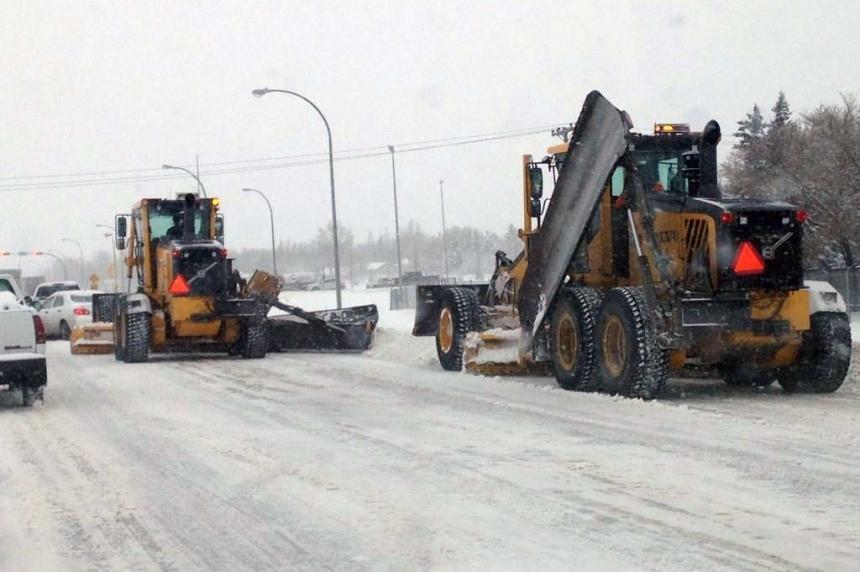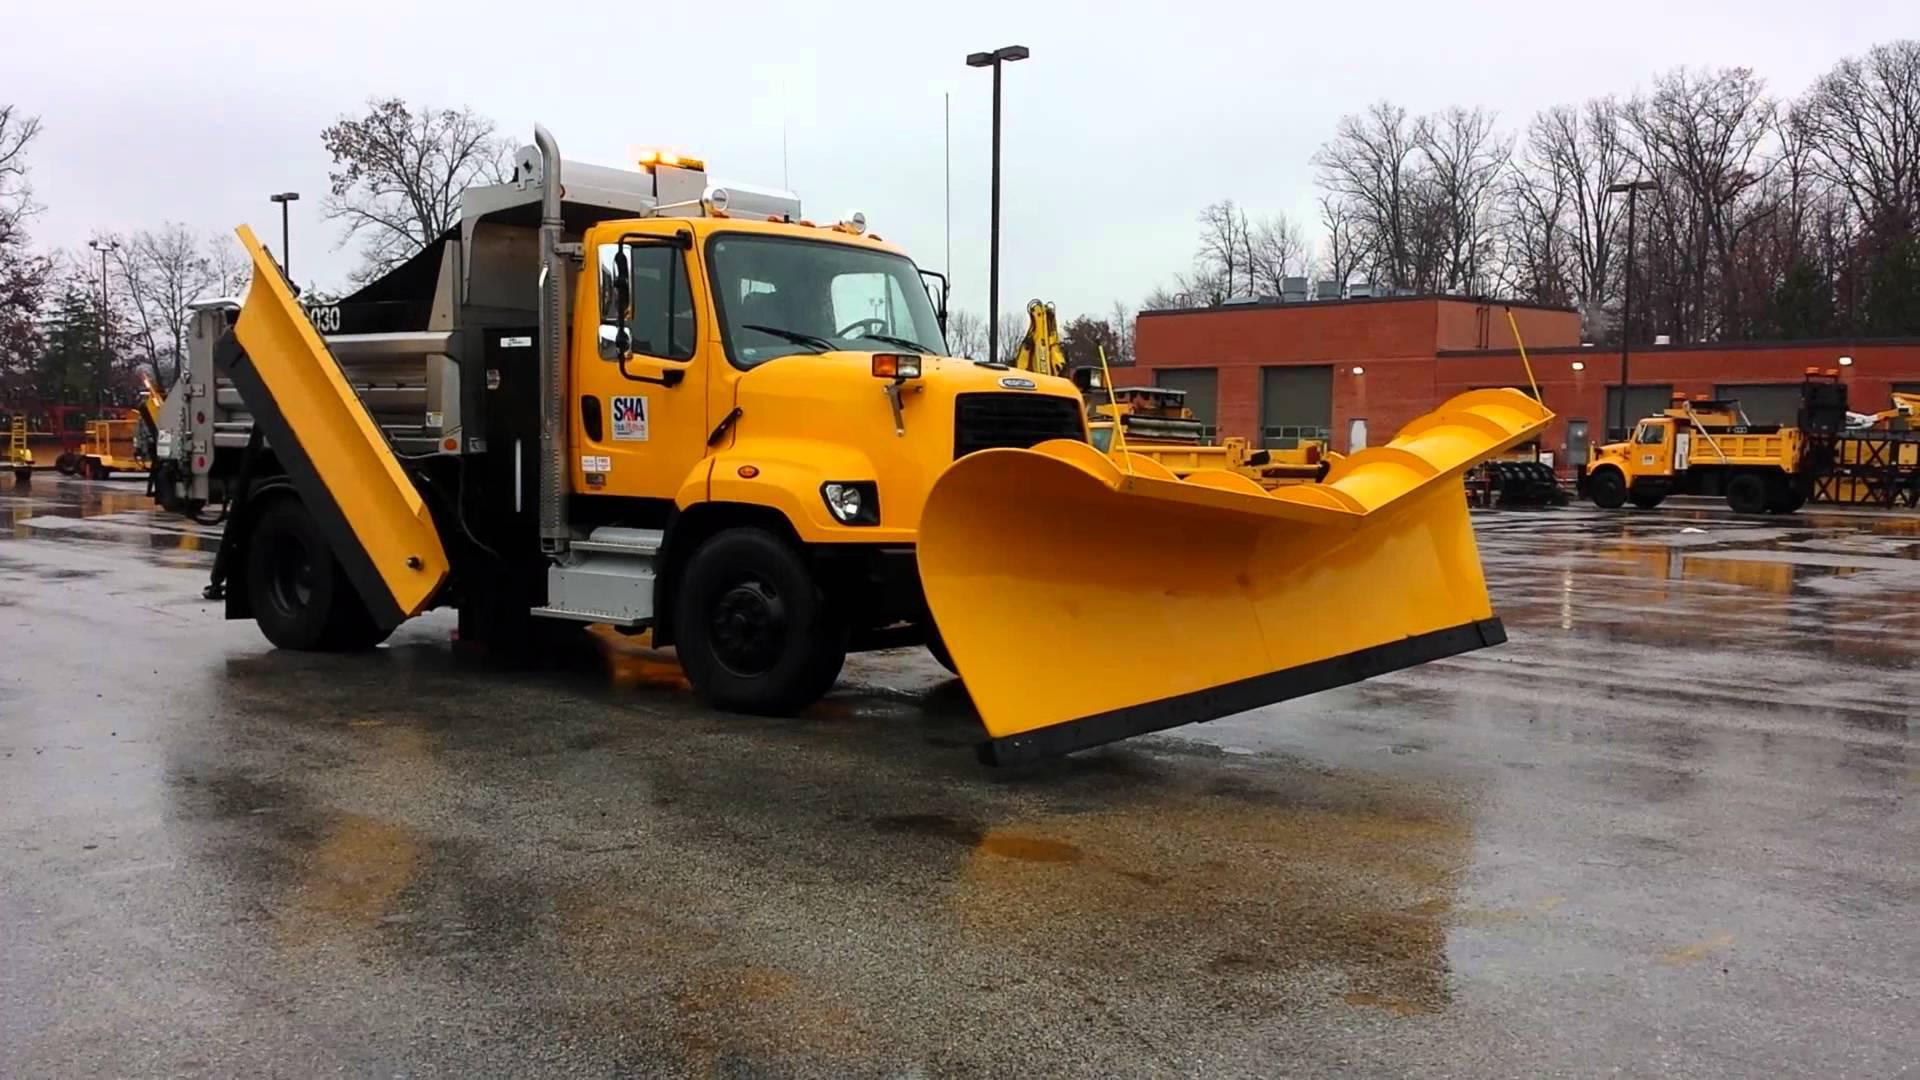The first image is the image on the left, the second image is the image on the right. Evaluate the accuracy of this statement regarding the images: "There is snow in the image on the left.". Is it true? Answer yes or no. Yes. The first image is the image on the left, the second image is the image on the right. Given the left and right images, does the statement "There is a snowplow on a snow-covered surface." hold true? Answer yes or no. Yes. 